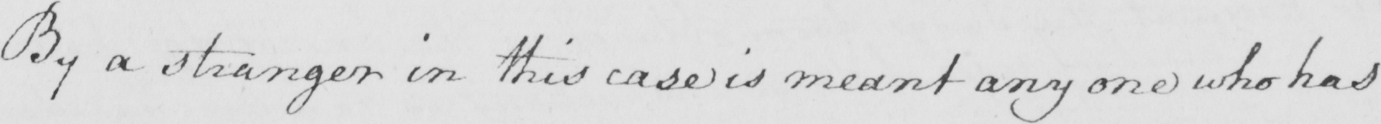What is written in this line of handwriting? By a stranger in this case is meant any one who has 